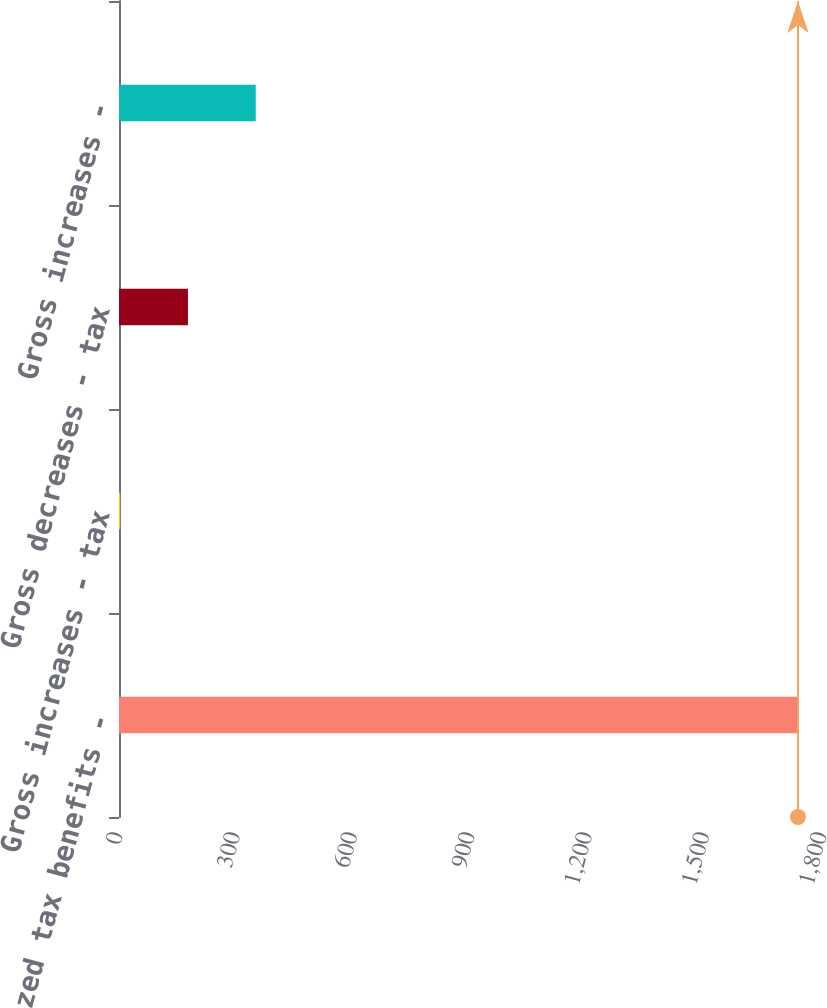Convert chart to OTSL. <chart><loc_0><loc_0><loc_500><loc_500><bar_chart><fcel>Unrecognized tax benefits -<fcel>Gross increases - tax<fcel>Gross decreases - tax<fcel>Gross increases -<nl><fcel>1736<fcel>3<fcel>176.3<fcel>349.6<nl></chart> 